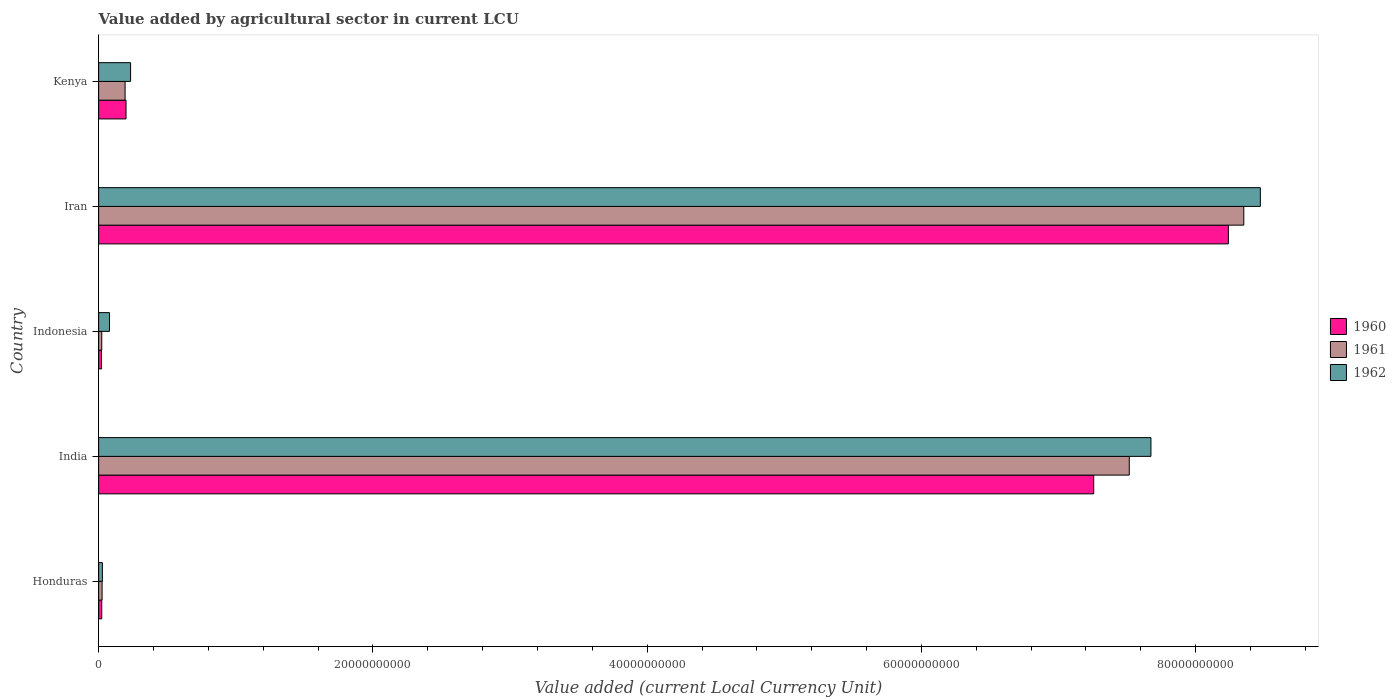How many different coloured bars are there?
Your answer should be compact. 3. Are the number of bars per tick equal to the number of legend labels?
Provide a succinct answer. Yes. How many bars are there on the 4th tick from the top?
Ensure brevity in your answer.  3. What is the value added by agricultural sector in 1960 in Kenya?
Make the answer very short. 2.00e+09. Across all countries, what is the maximum value added by agricultural sector in 1962?
Make the answer very short. 8.47e+1. Across all countries, what is the minimum value added by agricultural sector in 1960?
Provide a short and direct response. 2.12e+08. In which country was the value added by agricultural sector in 1962 maximum?
Offer a terse response. Iran. What is the total value added by agricultural sector in 1962 in the graph?
Make the answer very short. 1.65e+11. What is the difference between the value added by agricultural sector in 1962 in Iran and that in Kenya?
Provide a short and direct response. 8.24e+1. What is the difference between the value added by agricultural sector in 1960 in India and the value added by agricultural sector in 1962 in Indonesia?
Provide a succinct answer. 7.18e+1. What is the average value added by agricultural sector in 1961 per country?
Your response must be concise. 3.22e+1. What is the difference between the value added by agricultural sector in 1960 and value added by agricultural sector in 1962 in Honduras?
Provide a short and direct response. -4.75e+07. What is the ratio of the value added by agricultural sector in 1962 in India to that in Indonesia?
Provide a succinct answer. 96.77. Is the value added by agricultural sector in 1962 in India less than that in Kenya?
Your response must be concise. No. What is the difference between the highest and the second highest value added by agricultural sector in 1962?
Offer a terse response. 7.98e+09. What is the difference between the highest and the lowest value added by agricultural sector in 1962?
Offer a terse response. 8.44e+1. What does the 2nd bar from the top in India represents?
Ensure brevity in your answer.  1961. Is it the case that in every country, the sum of the value added by agricultural sector in 1962 and value added by agricultural sector in 1960 is greater than the value added by agricultural sector in 1961?
Offer a very short reply. Yes. How many countries are there in the graph?
Ensure brevity in your answer.  5. Are the values on the major ticks of X-axis written in scientific E-notation?
Your response must be concise. No. Does the graph contain grids?
Give a very brief answer. No. Where does the legend appear in the graph?
Offer a terse response. Center right. How are the legend labels stacked?
Your response must be concise. Vertical. What is the title of the graph?
Your answer should be very brief. Value added by agricultural sector in current LCU. What is the label or title of the X-axis?
Ensure brevity in your answer.  Value added (current Local Currency Unit). What is the Value added (current Local Currency Unit) of 1960 in Honduras?
Offer a very short reply. 2.27e+08. What is the Value added (current Local Currency Unit) of 1961 in Honduras?
Provide a succinct answer. 2.51e+08. What is the Value added (current Local Currency Unit) in 1962 in Honduras?
Offer a very short reply. 2.74e+08. What is the Value added (current Local Currency Unit) of 1960 in India?
Keep it short and to the point. 7.26e+1. What is the Value added (current Local Currency Unit) of 1961 in India?
Keep it short and to the point. 7.52e+1. What is the Value added (current Local Currency Unit) of 1962 in India?
Provide a succinct answer. 7.67e+1. What is the Value added (current Local Currency Unit) of 1960 in Indonesia?
Provide a short and direct response. 2.12e+08. What is the Value added (current Local Currency Unit) of 1961 in Indonesia?
Make the answer very short. 2.27e+08. What is the Value added (current Local Currency Unit) in 1962 in Indonesia?
Provide a succinct answer. 7.93e+08. What is the Value added (current Local Currency Unit) of 1960 in Iran?
Your answer should be compact. 8.24e+1. What is the Value added (current Local Currency Unit) in 1961 in Iran?
Offer a terse response. 8.35e+1. What is the Value added (current Local Currency Unit) of 1962 in Iran?
Provide a short and direct response. 8.47e+1. What is the Value added (current Local Currency Unit) in 1960 in Kenya?
Provide a short and direct response. 2.00e+09. What is the Value added (current Local Currency Unit) in 1961 in Kenya?
Provide a short and direct response. 1.93e+09. What is the Value added (current Local Currency Unit) in 1962 in Kenya?
Provide a succinct answer. 2.33e+09. Across all countries, what is the maximum Value added (current Local Currency Unit) in 1960?
Make the answer very short. 8.24e+1. Across all countries, what is the maximum Value added (current Local Currency Unit) of 1961?
Offer a terse response. 8.35e+1. Across all countries, what is the maximum Value added (current Local Currency Unit) in 1962?
Provide a succinct answer. 8.47e+1. Across all countries, what is the minimum Value added (current Local Currency Unit) of 1960?
Provide a short and direct response. 2.12e+08. Across all countries, what is the minimum Value added (current Local Currency Unit) of 1961?
Keep it short and to the point. 2.27e+08. Across all countries, what is the minimum Value added (current Local Currency Unit) of 1962?
Your response must be concise. 2.74e+08. What is the total Value added (current Local Currency Unit) of 1960 in the graph?
Provide a short and direct response. 1.57e+11. What is the total Value added (current Local Currency Unit) in 1961 in the graph?
Ensure brevity in your answer.  1.61e+11. What is the total Value added (current Local Currency Unit) in 1962 in the graph?
Offer a terse response. 1.65e+11. What is the difference between the Value added (current Local Currency Unit) of 1960 in Honduras and that in India?
Make the answer very short. -7.23e+1. What is the difference between the Value added (current Local Currency Unit) of 1961 in Honduras and that in India?
Keep it short and to the point. -7.49e+1. What is the difference between the Value added (current Local Currency Unit) in 1962 in Honduras and that in India?
Provide a succinct answer. -7.65e+1. What is the difference between the Value added (current Local Currency Unit) in 1960 in Honduras and that in Indonesia?
Give a very brief answer. 1.50e+07. What is the difference between the Value added (current Local Currency Unit) of 1961 in Honduras and that in Indonesia?
Offer a very short reply. 2.42e+07. What is the difference between the Value added (current Local Currency Unit) in 1962 in Honduras and that in Indonesia?
Your answer should be very brief. -5.18e+08. What is the difference between the Value added (current Local Currency Unit) in 1960 in Honduras and that in Iran?
Offer a very short reply. -8.22e+1. What is the difference between the Value added (current Local Currency Unit) of 1961 in Honduras and that in Iran?
Provide a succinct answer. -8.33e+1. What is the difference between the Value added (current Local Currency Unit) in 1962 in Honduras and that in Iran?
Offer a very short reply. -8.44e+1. What is the difference between the Value added (current Local Currency Unit) in 1960 in Honduras and that in Kenya?
Give a very brief answer. -1.77e+09. What is the difference between the Value added (current Local Currency Unit) in 1961 in Honduras and that in Kenya?
Make the answer very short. -1.68e+09. What is the difference between the Value added (current Local Currency Unit) in 1962 in Honduras and that in Kenya?
Offer a very short reply. -2.06e+09. What is the difference between the Value added (current Local Currency Unit) of 1960 in India and that in Indonesia?
Offer a very short reply. 7.24e+1. What is the difference between the Value added (current Local Currency Unit) of 1961 in India and that in Indonesia?
Your response must be concise. 7.49e+1. What is the difference between the Value added (current Local Currency Unit) of 1962 in India and that in Indonesia?
Offer a terse response. 7.59e+1. What is the difference between the Value added (current Local Currency Unit) in 1960 in India and that in Iran?
Keep it short and to the point. -9.82e+09. What is the difference between the Value added (current Local Currency Unit) of 1961 in India and that in Iran?
Provide a short and direct response. -8.35e+09. What is the difference between the Value added (current Local Currency Unit) in 1962 in India and that in Iran?
Offer a very short reply. -7.98e+09. What is the difference between the Value added (current Local Currency Unit) of 1960 in India and that in Kenya?
Provide a short and direct response. 7.06e+1. What is the difference between the Value added (current Local Currency Unit) in 1961 in India and that in Kenya?
Your answer should be very brief. 7.32e+1. What is the difference between the Value added (current Local Currency Unit) of 1962 in India and that in Kenya?
Your answer should be compact. 7.44e+1. What is the difference between the Value added (current Local Currency Unit) of 1960 in Indonesia and that in Iran?
Your answer should be very brief. -8.22e+1. What is the difference between the Value added (current Local Currency Unit) in 1961 in Indonesia and that in Iran?
Give a very brief answer. -8.33e+1. What is the difference between the Value added (current Local Currency Unit) of 1962 in Indonesia and that in Iran?
Give a very brief answer. -8.39e+1. What is the difference between the Value added (current Local Currency Unit) of 1960 in Indonesia and that in Kenya?
Your answer should be very brief. -1.79e+09. What is the difference between the Value added (current Local Currency Unit) in 1961 in Indonesia and that in Kenya?
Provide a short and direct response. -1.70e+09. What is the difference between the Value added (current Local Currency Unit) of 1962 in Indonesia and that in Kenya?
Keep it short and to the point. -1.54e+09. What is the difference between the Value added (current Local Currency Unit) of 1960 in Iran and that in Kenya?
Give a very brief answer. 8.04e+1. What is the difference between the Value added (current Local Currency Unit) in 1961 in Iran and that in Kenya?
Keep it short and to the point. 8.16e+1. What is the difference between the Value added (current Local Currency Unit) in 1962 in Iran and that in Kenya?
Ensure brevity in your answer.  8.24e+1. What is the difference between the Value added (current Local Currency Unit) in 1960 in Honduras and the Value added (current Local Currency Unit) in 1961 in India?
Make the answer very short. -7.49e+1. What is the difference between the Value added (current Local Currency Unit) of 1960 in Honduras and the Value added (current Local Currency Unit) of 1962 in India?
Offer a very short reply. -7.65e+1. What is the difference between the Value added (current Local Currency Unit) in 1961 in Honduras and the Value added (current Local Currency Unit) in 1962 in India?
Provide a succinct answer. -7.65e+1. What is the difference between the Value added (current Local Currency Unit) in 1960 in Honduras and the Value added (current Local Currency Unit) in 1962 in Indonesia?
Your answer should be compact. -5.66e+08. What is the difference between the Value added (current Local Currency Unit) in 1961 in Honduras and the Value added (current Local Currency Unit) in 1962 in Indonesia?
Offer a terse response. -5.42e+08. What is the difference between the Value added (current Local Currency Unit) in 1960 in Honduras and the Value added (current Local Currency Unit) in 1961 in Iran?
Your response must be concise. -8.33e+1. What is the difference between the Value added (current Local Currency Unit) in 1960 in Honduras and the Value added (current Local Currency Unit) in 1962 in Iran?
Offer a terse response. -8.45e+1. What is the difference between the Value added (current Local Currency Unit) of 1961 in Honduras and the Value added (current Local Currency Unit) of 1962 in Iran?
Keep it short and to the point. -8.45e+1. What is the difference between the Value added (current Local Currency Unit) in 1960 in Honduras and the Value added (current Local Currency Unit) in 1961 in Kenya?
Ensure brevity in your answer.  -1.70e+09. What is the difference between the Value added (current Local Currency Unit) in 1960 in Honduras and the Value added (current Local Currency Unit) in 1962 in Kenya?
Your answer should be compact. -2.10e+09. What is the difference between the Value added (current Local Currency Unit) in 1961 in Honduras and the Value added (current Local Currency Unit) in 1962 in Kenya?
Your response must be concise. -2.08e+09. What is the difference between the Value added (current Local Currency Unit) in 1960 in India and the Value added (current Local Currency Unit) in 1961 in Indonesia?
Provide a succinct answer. 7.23e+1. What is the difference between the Value added (current Local Currency Unit) in 1960 in India and the Value added (current Local Currency Unit) in 1962 in Indonesia?
Make the answer very short. 7.18e+1. What is the difference between the Value added (current Local Currency Unit) in 1961 in India and the Value added (current Local Currency Unit) in 1962 in Indonesia?
Keep it short and to the point. 7.44e+1. What is the difference between the Value added (current Local Currency Unit) in 1960 in India and the Value added (current Local Currency Unit) in 1961 in Iran?
Give a very brief answer. -1.09e+1. What is the difference between the Value added (current Local Currency Unit) in 1960 in India and the Value added (current Local Currency Unit) in 1962 in Iran?
Provide a succinct answer. -1.22e+1. What is the difference between the Value added (current Local Currency Unit) of 1961 in India and the Value added (current Local Currency Unit) of 1962 in Iran?
Ensure brevity in your answer.  -9.56e+09. What is the difference between the Value added (current Local Currency Unit) of 1960 in India and the Value added (current Local Currency Unit) of 1961 in Kenya?
Give a very brief answer. 7.06e+1. What is the difference between the Value added (current Local Currency Unit) in 1960 in India and the Value added (current Local Currency Unit) in 1962 in Kenya?
Keep it short and to the point. 7.02e+1. What is the difference between the Value added (current Local Currency Unit) in 1961 in India and the Value added (current Local Currency Unit) in 1962 in Kenya?
Offer a terse response. 7.28e+1. What is the difference between the Value added (current Local Currency Unit) of 1960 in Indonesia and the Value added (current Local Currency Unit) of 1961 in Iran?
Provide a succinct answer. -8.33e+1. What is the difference between the Value added (current Local Currency Unit) of 1960 in Indonesia and the Value added (current Local Currency Unit) of 1962 in Iran?
Offer a very short reply. -8.45e+1. What is the difference between the Value added (current Local Currency Unit) of 1961 in Indonesia and the Value added (current Local Currency Unit) of 1962 in Iran?
Make the answer very short. -8.45e+1. What is the difference between the Value added (current Local Currency Unit) in 1960 in Indonesia and the Value added (current Local Currency Unit) in 1961 in Kenya?
Make the answer very short. -1.72e+09. What is the difference between the Value added (current Local Currency Unit) in 1960 in Indonesia and the Value added (current Local Currency Unit) in 1962 in Kenya?
Ensure brevity in your answer.  -2.12e+09. What is the difference between the Value added (current Local Currency Unit) in 1961 in Indonesia and the Value added (current Local Currency Unit) in 1962 in Kenya?
Offer a very short reply. -2.10e+09. What is the difference between the Value added (current Local Currency Unit) in 1960 in Iran and the Value added (current Local Currency Unit) in 1961 in Kenya?
Your answer should be compact. 8.05e+1. What is the difference between the Value added (current Local Currency Unit) of 1960 in Iran and the Value added (current Local Currency Unit) of 1962 in Kenya?
Your answer should be compact. 8.01e+1. What is the difference between the Value added (current Local Currency Unit) of 1961 in Iran and the Value added (current Local Currency Unit) of 1962 in Kenya?
Provide a short and direct response. 8.12e+1. What is the average Value added (current Local Currency Unit) of 1960 per country?
Provide a succinct answer. 3.15e+1. What is the average Value added (current Local Currency Unit) of 1961 per country?
Ensure brevity in your answer.  3.22e+1. What is the average Value added (current Local Currency Unit) of 1962 per country?
Your answer should be compact. 3.30e+1. What is the difference between the Value added (current Local Currency Unit) in 1960 and Value added (current Local Currency Unit) in 1961 in Honduras?
Keep it short and to the point. -2.42e+07. What is the difference between the Value added (current Local Currency Unit) of 1960 and Value added (current Local Currency Unit) of 1962 in Honduras?
Provide a succinct answer. -4.75e+07. What is the difference between the Value added (current Local Currency Unit) of 1961 and Value added (current Local Currency Unit) of 1962 in Honduras?
Your answer should be very brief. -2.33e+07. What is the difference between the Value added (current Local Currency Unit) of 1960 and Value added (current Local Currency Unit) of 1961 in India?
Ensure brevity in your answer.  -2.59e+09. What is the difference between the Value added (current Local Currency Unit) of 1960 and Value added (current Local Currency Unit) of 1962 in India?
Offer a very short reply. -4.17e+09. What is the difference between the Value added (current Local Currency Unit) of 1961 and Value added (current Local Currency Unit) of 1962 in India?
Provide a succinct answer. -1.58e+09. What is the difference between the Value added (current Local Currency Unit) of 1960 and Value added (current Local Currency Unit) of 1961 in Indonesia?
Your answer should be very brief. -1.50e+07. What is the difference between the Value added (current Local Currency Unit) of 1960 and Value added (current Local Currency Unit) of 1962 in Indonesia?
Your answer should be compact. -5.81e+08. What is the difference between the Value added (current Local Currency Unit) in 1961 and Value added (current Local Currency Unit) in 1962 in Indonesia?
Your answer should be very brief. -5.66e+08. What is the difference between the Value added (current Local Currency Unit) of 1960 and Value added (current Local Currency Unit) of 1961 in Iran?
Your response must be concise. -1.12e+09. What is the difference between the Value added (current Local Currency Unit) in 1960 and Value added (current Local Currency Unit) in 1962 in Iran?
Your answer should be very brief. -2.33e+09. What is the difference between the Value added (current Local Currency Unit) in 1961 and Value added (current Local Currency Unit) in 1962 in Iran?
Your response must be concise. -1.21e+09. What is the difference between the Value added (current Local Currency Unit) of 1960 and Value added (current Local Currency Unit) of 1961 in Kenya?
Provide a succinct answer. 6.79e+07. What is the difference between the Value added (current Local Currency Unit) in 1960 and Value added (current Local Currency Unit) in 1962 in Kenya?
Your response must be concise. -3.32e+08. What is the difference between the Value added (current Local Currency Unit) of 1961 and Value added (current Local Currency Unit) of 1962 in Kenya?
Offer a terse response. -4.00e+08. What is the ratio of the Value added (current Local Currency Unit) of 1960 in Honduras to that in India?
Your answer should be compact. 0. What is the ratio of the Value added (current Local Currency Unit) in 1961 in Honduras to that in India?
Provide a short and direct response. 0. What is the ratio of the Value added (current Local Currency Unit) in 1962 in Honduras to that in India?
Keep it short and to the point. 0. What is the ratio of the Value added (current Local Currency Unit) of 1960 in Honduras to that in Indonesia?
Provide a short and direct response. 1.07. What is the ratio of the Value added (current Local Currency Unit) of 1961 in Honduras to that in Indonesia?
Keep it short and to the point. 1.11. What is the ratio of the Value added (current Local Currency Unit) of 1962 in Honduras to that in Indonesia?
Provide a short and direct response. 0.35. What is the ratio of the Value added (current Local Currency Unit) of 1960 in Honduras to that in Iran?
Your answer should be very brief. 0. What is the ratio of the Value added (current Local Currency Unit) in 1961 in Honduras to that in Iran?
Give a very brief answer. 0. What is the ratio of the Value added (current Local Currency Unit) in 1962 in Honduras to that in Iran?
Offer a terse response. 0. What is the ratio of the Value added (current Local Currency Unit) of 1960 in Honduras to that in Kenya?
Give a very brief answer. 0.11. What is the ratio of the Value added (current Local Currency Unit) in 1961 in Honduras to that in Kenya?
Your answer should be very brief. 0.13. What is the ratio of the Value added (current Local Currency Unit) of 1962 in Honduras to that in Kenya?
Your answer should be compact. 0.12. What is the ratio of the Value added (current Local Currency Unit) in 1960 in India to that in Indonesia?
Offer a terse response. 342.29. What is the ratio of the Value added (current Local Currency Unit) of 1961 in India to that in Indonesia?
Offer a very short reply. 331.1. What is the ratio of the Value added (current Local Currency Unit) of 1962 in India to that in Indonesia?
Your answer should be very brief. 96.77. What is the ratio of the Value added (current Local Currency Unit) of 1960 in India to that in Iran?
Give a very brief answer. 0.88. What is the ratio of the Value added (current Local Currency Unit) in 1961 in India to that in Iran?
Offer a very short reply. 0.9. What is the ratio of the Value added (current Local Currency Unit) in 1962 in India to that in Iran?
Provide a short and direct response. 0.91. What is the ratio of the Value added (current Local Currency Unit) of 1960 in India to that in Kenya?
Offer a very short reply. 36.32. What is the ratio of the Value added (current Local Currency Unit) in 1961 in India to that in Kenya?
Give a very brief answer. 38.94. What is the ratio of the Value added (current Local Currency Unit) of 1962 in India to that in Kenya?
Ensure brevity in your answer.  32.94. What is the ratio of the Value added (current Local Currency Unit) of 1960 in Indonesia to that in Iran?
Make the answer very short. 0. What is the ratio of the Value added (current Local Currency Unit) of 1961 in Indonesia to that in Iran?
Your answer should be compact. 0. What is the ratio of the Value added (current Local Currency Unit) of 1962 in Indonesia to that in Iran?
Your answer should be compact. 0.01. What is the ratio of the Value added (current Local Currency Unit) of 1960 in Indonesia to that in Kenya?
Give a very brief answer. 0.11. What is the ratio of the Value added (current Local Currency Unit) of 1961 in Indonesia to that in Kenya?
Offer a terse response. 0.12. What is the ratio of the Value added (current Local Currency Unit) of 1962 in Indonesia to that in Kenya?
Keep it short and to the point. 0.34. What is the ratio of the Value added (current Local Currency Unit) of 1960 in Iran to that in Kenya?
Provide a succinct answer. 41.24. What is the ratio of the Value added (current Local Currency Unit) of 1961 in Iran to that in Kenya?
Your response must be concise. 43.27. What is the ratio of the Value added (current Local Currency Unit) of 1962 in Iran to that in Kenya?
Your answer should be compact. 36.36. What is the difference between the highest and the second highest Value added (current Local Currency Unit) in 1960?
Your answer should be very brief. 9.82e+09. What is the difference between the highest and the second highest Value added (current Local Currency Unit) in 1961?
Your response must be concise. 8.35e+09. What is the difference between the highest and the second highest Value added (current Local Currency Unit) of 1962?
Ensure brevity in your answer.  7.98e+09. What is the difference between the highest and the lowest Value added (current Local Currency Unit) in 1960?
Your answer should be very brief. 8.22e+1. What is the difference between the highest and the lowest Value added (current Local Currency Unit) of 1961?
Your response must be concise. 8.33e+1. What is the difference between the highest and the lowest Value added (current Local Currency Unit) in 1962?
Give a very brief answer. 8.44e+1. 